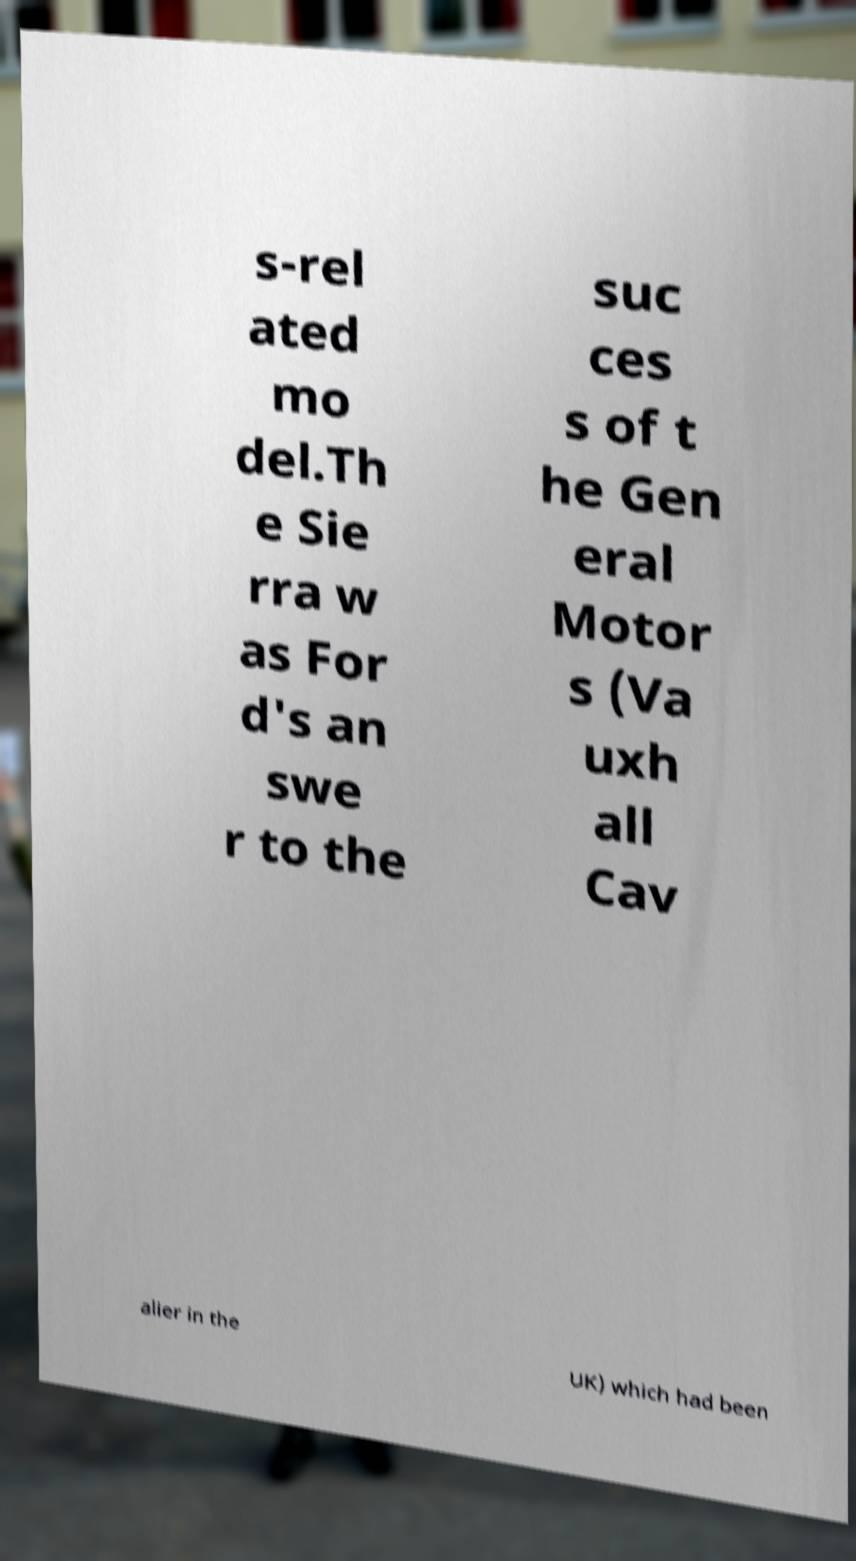There's text embedded in this image that I need extracted. Can you transcribe it verbatim? s-rel ated mo del.Th e Sie rra w as For d's an swe r to the suc ces s of t he Gen eral Motor s (Va uxh all Cav alier in the UK) which had been 